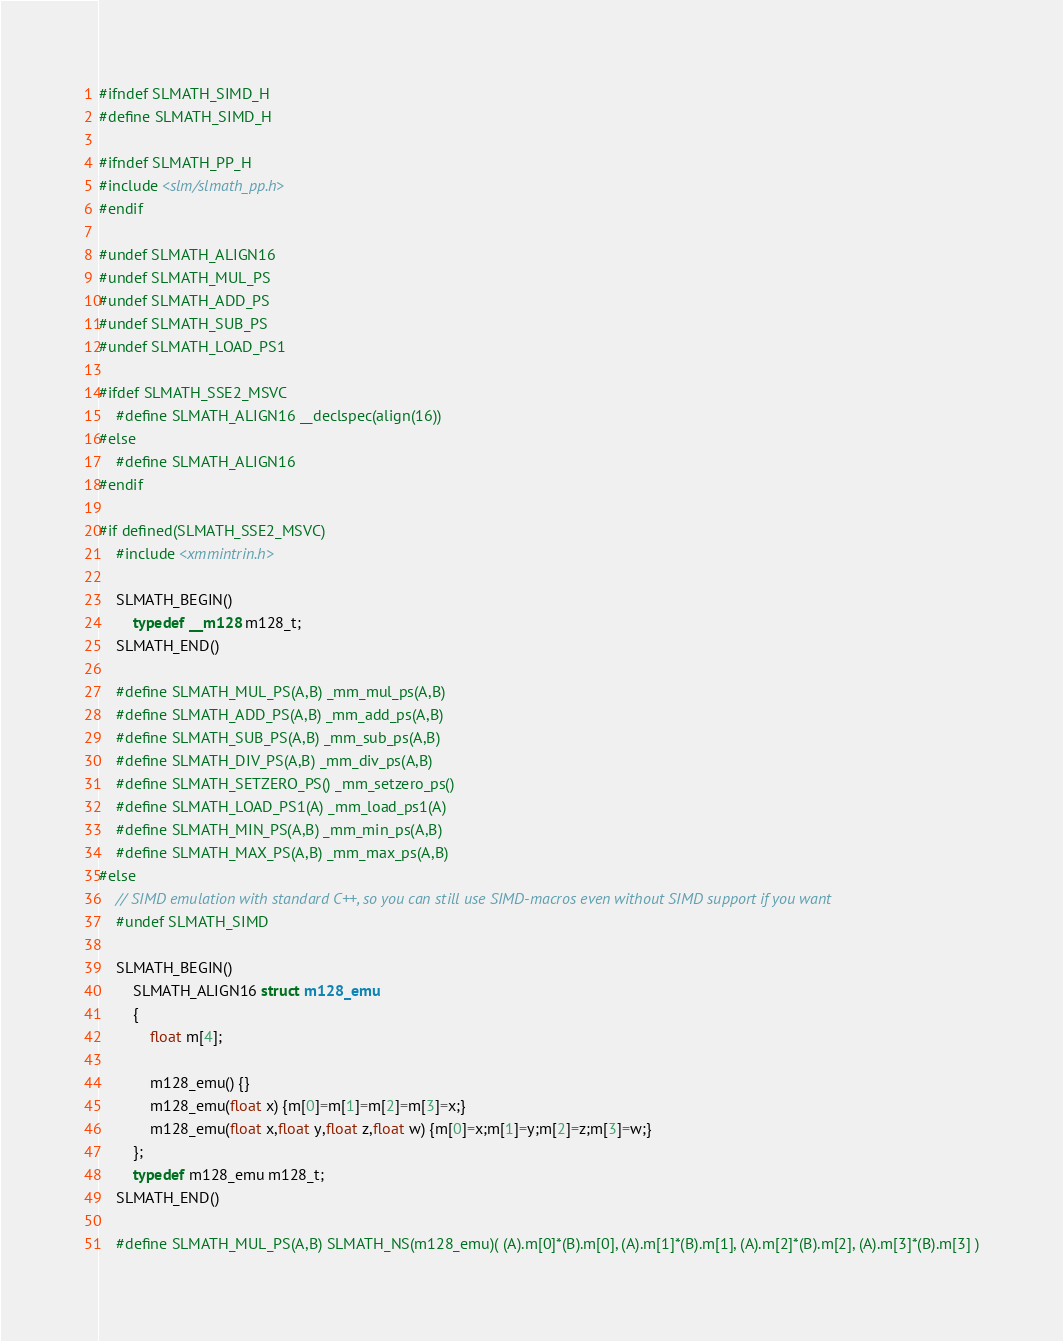<code> <loc_0><loc_0><loc_500><loc_500><_C_>#ifndef SLMATH_SIMD_H
#define SLMATH_SIMD_H

#ifndef SLMATH_PP_H
#include <slm/slmath_pp.h>
#endif

#undef SLMATH_ALIGN16
#undef SLMATH_MUL_PS
#undef SLMATH_ADD_PS
#undef SLMATH_SUB_PS
#undef SLMATH_LOAD_PS1

#ifdef SLMATH_SSE2_MSVC
	#define SLMATH_ALIGN16 __declspec(align(16))
#else
	#define SLMATH_ALIGN16
#endif

#if defined(SLMATH_SSE2_MSVC)
	#include <xmmintrin.h>

	SLMATH_BEGIN()
		typedef __m128 m128_t;
	SLMATH_END()

	#define SLMATH_MUL_PS(A,B) _mm_mul_ps(A,B)
	#define SLMATH_ADD_PS(A,B) _mm_add_ps(A,B)
	#define SLMATH_SUB_PS(A,B) _mm_sub_ps(A,B)
	#define SLMATH_DIV_PS(A,B) _mm_div_ps(A,B)
	#define SLMATH_SETZERO_PS() _mm_setzero_ps()
	#define SLMATH_LOAD_PS1(A) _mm_load_ps1(A)
	#define SLMATH_MIN_PS(A,B) _mm_min_ps(A,B)
	#define SLMATH_MAX_PS(A,B) _mm_max_ps(A,B)
#else 
	// SIMD emulation with standard C++, so you can still use SIMD-macros even without SIMD support if you want
	#undef SLMATH_SIMD

	SLMATH_BEGIN()
		SLMATH_ALIGN16 struct m128_emu
		{
			float m[4]; 
			
			m128_emu() {} 
			m128_emu(float x) {m[0]=m[1]=m[2]=m[3]=x;} 
			m128_emu(float x,float y,float z,float w) {m[0]=x;m[1]=y;m[2]=z;m[3]=w;} 
		};
		typedef m128_emu m128_t;
	SLMATH_END()

	#define SLMATH_MUL_PS(A,B) SLMATH_NS(m128_emu)( (A).m[0]*(B).m[0], (A).m[1]*(B).m[1], (A).m[2]*(B).m[2], (A).m[3]*(B).m[3] )</code> 